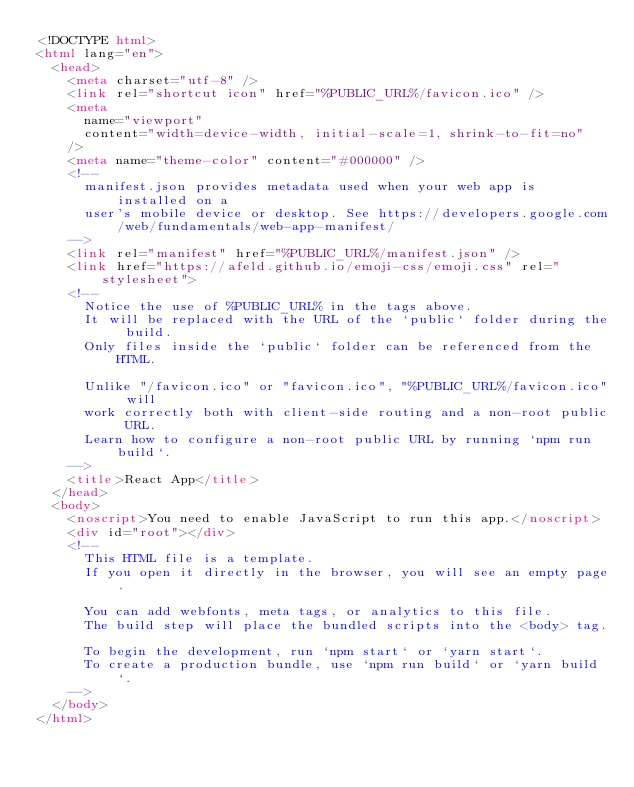Convert code to text. <code><loc_0><loc_0><loc_500><loc_500><_HTML_><!DOCTYPE html>
<html lang="en">
  <head>
    <meta charset="utf-8" />
    <link rel="shortcut icon" href="%PUBLIC_URL%/favicon.ico" />
    <meta
      name="viewport"
      content="width=device-width, initial-scale=1, shrink-to-fit=no"
    />
    <meta name="theme-color" content="#000000" />
    <!--
      manifest.json provides metadata used when your web app is installed on a
      user's mobile device or desktop. See https://developers.google.com/web/fundamentals/web-app-manifest/
    -->
    <link rel="manifest" href="%PUBLIC_URL%/manifest.json" />
    <link href="https://afeld.github.io/emoji-css/emoji.css" rel="stylesheet">
    <!--
      Notice the use of %PUBLIC_URL% in the tags above.
      It will be replaced with the URL of the `public` folder during the build.
      Only files inside the `public` folder can be referenced from the HTML.

      Unlike "/favicon.ico" or "favicon.ico", "%PUBLIC_URL%/favicon.ico" will
      work correctly both with client-side routing and a non-root public URL.
      Learn how to configure a non-root public URL by running `npm run build`.
    -->
    <title>React App</title>
  </head>
  <body>
    <noscript>You need to enable JavaScript to run this app.</noscript>
    <div id="root"></div>
    <!--
      This HTML file is a template.
      If you open it directly in the browser, you will see an empty page.

      You can add webfonts, meta tags, or analytics to this file.
      The build step will place the bundled scripts into the <body> tag.

      To begin the development, run `npm start` or `yarn start`.
      To create a production bundle, use `npm run build` or `yarn build`.
    -->
  </body>
</html>
</code> 